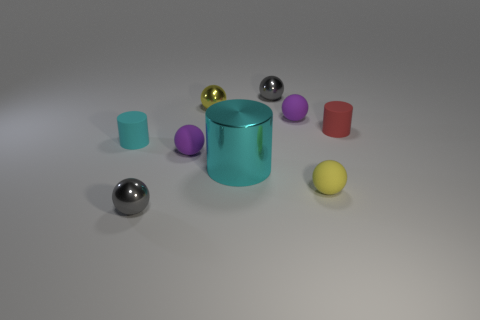How would you describe the material properties of these objects as depicted in the image? The objects exhibit different degrees of reflectivity and texture. Some appear glossy, suggesting they are made of a reflective material like plastic or metal, while others have a matte finish that could represent a more porous material. 